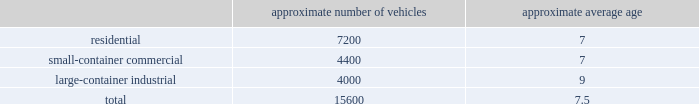We realize synergies from consolidating businesses into our existing operations , whether through acquisitions or public-private partnerships , which allow us to reduce capital and expense requirements associated with truck routing , personnel , fleet maintenance , inventories and back-office administration .
Operating model the goal of our operating model pillar is to deliver a consistent , high quality service to all of our customers through the republic way : one way .
Everywhere .
Every day .
This approach of developing standardized processes with rigorous controls and tracking allows us to leverage our scale and deliver durable operational excellence .
The republic way is the key to harnessing the best of what we do as operators and translating that across all facets of our business .
A key enabler of the republic way is our organizational structure that fosters a high performance culture by maintaining 360 degree accountability and full profit and loss responsibility with general management , supported by a functional structure to provide subject matter expertise .
This structure allows us to take advantage of our scale by coordinating functionally across all of our markets , while empowering local management to respond to unique market dynamics .
We have rolled out several productivity and cost control initiatives designed to deliver the best service possible to our customers in the most efficient and environmentally sound way .
Fleet automation approximately 72% ( 72 % ) of our residential routes have been converted to automated single driver trucks .
By converting our residential routes to automated service , we reduce labor costs , improve driver productivity , decrease emissions and create a safer work environment for our employees .
Additionally , communities using automated vehicles have higher participation rates in recycling programs , thereby complementing our initiative to expand our recycling capabilities .
Fleet conversion to compressed natural gas ( cng ) approximately 16% ( 16 % ) of our fleet operates on cng .
We expect to continue our gradual fleet conversion to cng , our preferred alternative fuel technology , as part of our ordinary annual fleet replacement process .
We believe a gradual fleet conversion is most prudent to realize the full value of our previous fleet investments .
Approximately 33% ( 33 % ) of our replacement vehicle purchases during 2015 were cng vehicles .
We believe using cng vehicles provides us a competitive advantage in communities with strict clean emission initiatives that focus on protecting the environment .
Although upfront costs are higher , using cng reduces our overall fleet operating costs through lower fuel expenses .
As of december 31 , 2015 , we operated 38 cng fueling stations .
Standardized maintenance based on an industry trade publication , we operate the ninth largest vocational fleet in the united states .
As of december 31 , 2015 , our average fleet age in years , by line of business , was as follows : approximate number of vehicles approximate average age .
Onefleet , our standardized vehicle maintenance program , enables us to use best practices for fleet management , truck care and maintenance .
Through standardization of core functions , we believe we can minimize variability .
As of december 31 , 2015 what was the ratio of vehicles for the residential to the large-container industrial? 
Rationale: there are 1.8 residential vehicles for each large-container industrial
Computations: (7200 / 4000)
Answer: 1.8. 